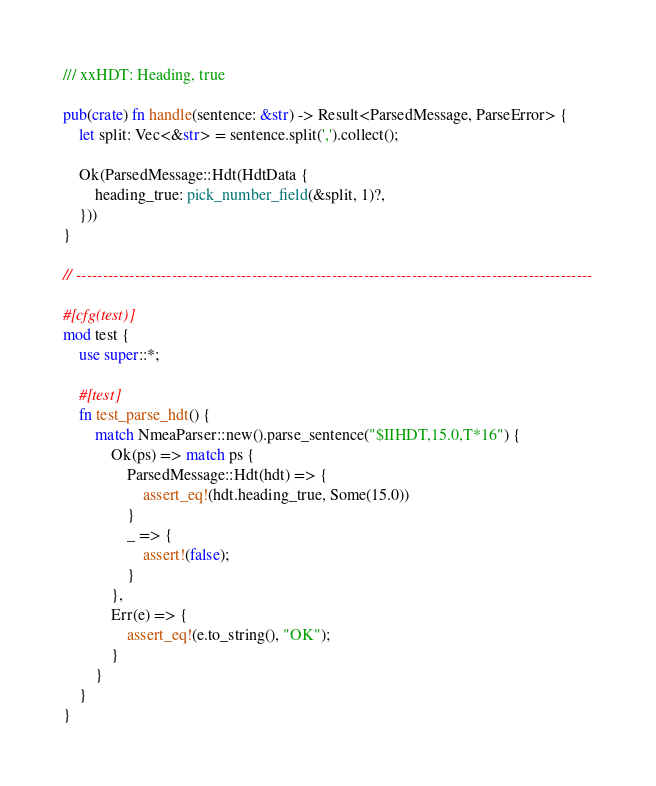<code> <loc_0><loc_0><loc_500><loc_500><_Rust_>
/// xxHDT: Heading, true

pub(crate) fn handle(sentence: &str) -> Result<ParsedMessage, ParseError> {
    let split: Vec<&str> = sentence.split(',').collect();

    Ok(ParsedMessage::Hdt(HdtData {
        heading_true: pick_number_field(&split, 1)?,
    }))
}

// -------------------------------------------------------------------------------------------------

#[cfg(test)]
mod test {
    use super::*;

    #[test]
    fn test_parse_hdt() {
        match NmeaParser::new().parse_sentence("$IIHDT,15.0,T*16") {
            Ok(ps) => match ps {
                ParsedMessage::Hdt(hdt) => {
                    assert_eq!(hdt.heading_true, Some(15.0))
                }
                _ => {
                    assert!(false);
                }
            },
            Err(e) => {
                assert_eq!(e.to_string(), "OK");
            }
        }
    }
}
</code> 